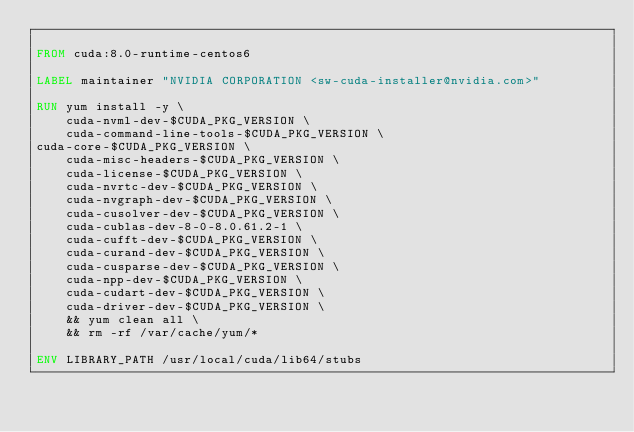Convert code to text. <code><loc_0><loc_0><loc_500><loc_500><_Dockerfile_>
FROM cuda:8.0-runtime-centos6

LABEL maintainer "NVIDIA CORPORATION <sw-cuda-installer@nvidia.com>"

RUN yum install -y \
    cuda-nvml-dev-$CUDA_PKG_VERSION \
    cuda-command-line-tools-$CUDA_PKG_VERSION \
cuda-core-$CUDA_PKG_VERSION \
    cuda-misc-headers-$CUDA_PKG_VERSION \
    cuda-license-$CUDA_PKG_VERSION \
    cuda-nvrtc-dev-$CUDA_PKG_VERSION \
    cuda-nvgraph-dev-$CUDA_PKG_VERSION \
    cuda-cusolver-dev-$CUDA_PKG_VERSION \
    cuda-cublas-dev-8-0-8.0.61.2-1 \
    cuda-cufft-dev-$CUDA_PKG_VERSION \
    cuda-curand-dev-$CUDA_PKG_VERSION \
    cuda-cusparse-dev-$CUDA_PKG_VERSION \
    cuda-npp-dev-$CUDA_PKG_VERSION \
    cuda-cudart-dev-$CUDA_PKG_VERSION \
    cuda-driver-dev-$CUDA_PKG_VERSION \
    && yum clean all \
    && rm -rf /var/cache/yum/*

ENV LIBRARY_PATH /usr/local/cuda/lib64/stubs</code> 